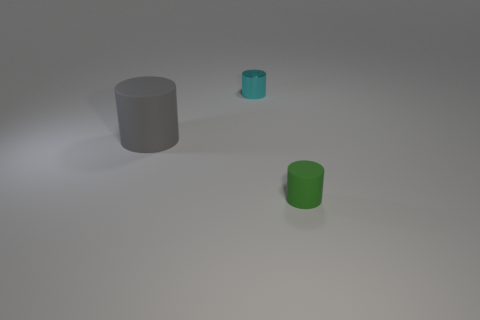If these objects were containers, what might their capacities be? Judging by their sizes, if these cylinders are hollow containers, the gray one would have the largest capacity, followed by the green, and then the cyan, which would have the smallest capacity due to its size in comparison. 